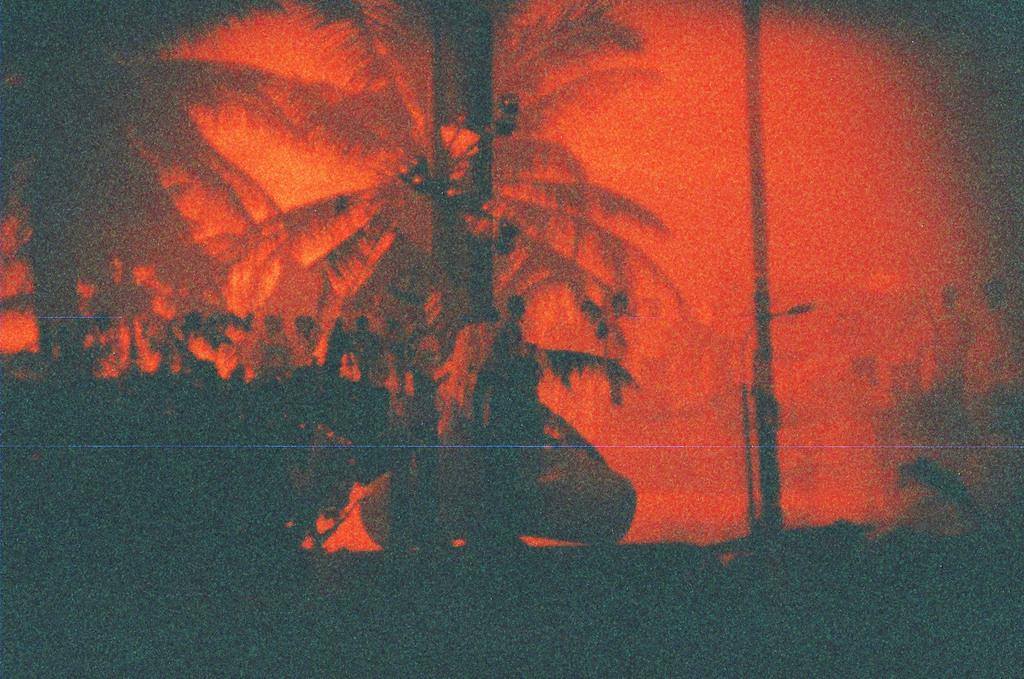What type of vegetation is present in the image? There are trees in the image. What other object can be seen in the image? There is a pole in the image. Can you describe the image in terms of its editing? The image is edited. How many lizards can be seen climbing the trees in the image? There are no lizards present in the image; it only features trees and a pole. 